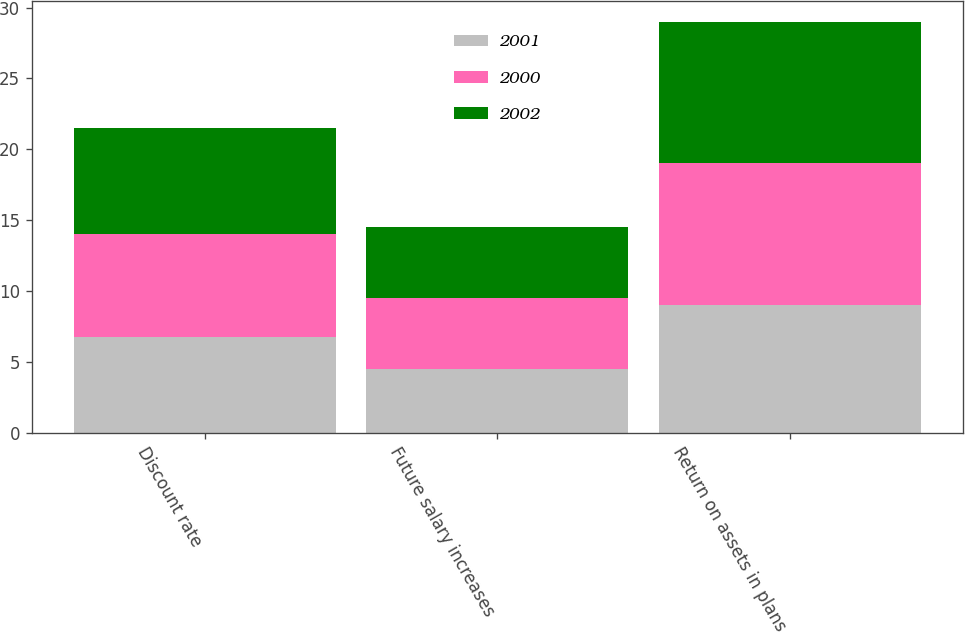Convert chart. <chart><loc_0><loc_0><loc_500><loc_500><stacked_bar_chart><ecel><fcel>Discount rate<fcel>Future salary increases<fcel>Return on assets in plans<nl><fcel>2001<fcel>6.75<fcel>4.5<fcel>9<nl><fcel>2000<fcel>7.25<fcel>5<fcel>10<nl><fcel>2002<fcel>7.5<fcel>5<fcel>10<nl></chart> 